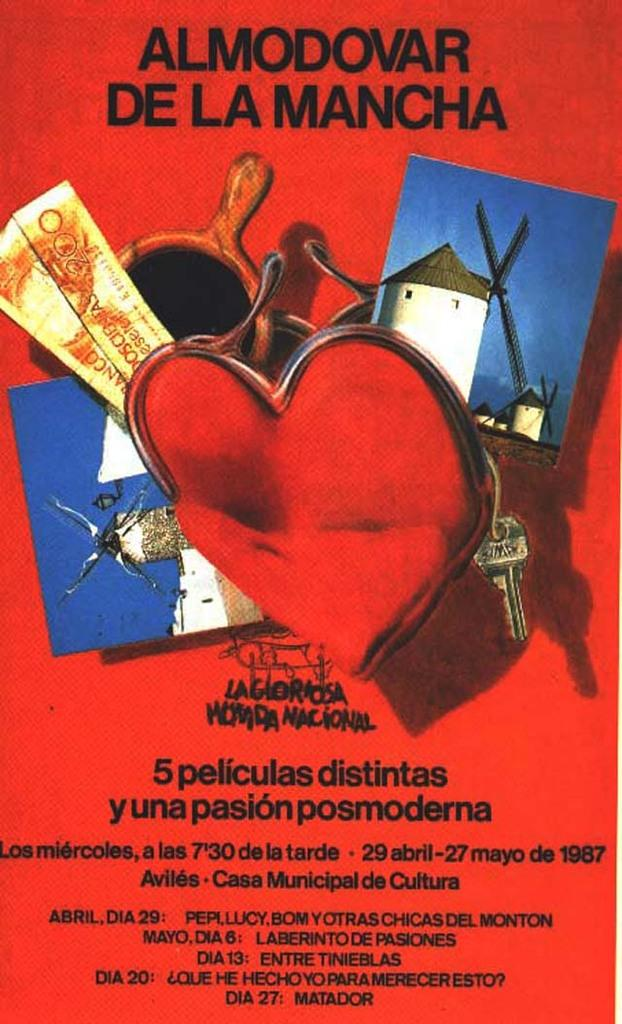What type of object is depicted in the image? The image appears to be a book's outer cover. What can be seen on the book's cover? There are images on the book's cover. Is there any text present on the book's cover? Yes, there is text at the bottom of the book's cover. Can you see a van in the image? There is no van present in the image. Is there a bell hanging from the book's cover in the image? There is no bell depicted on the book's cover in the image. 